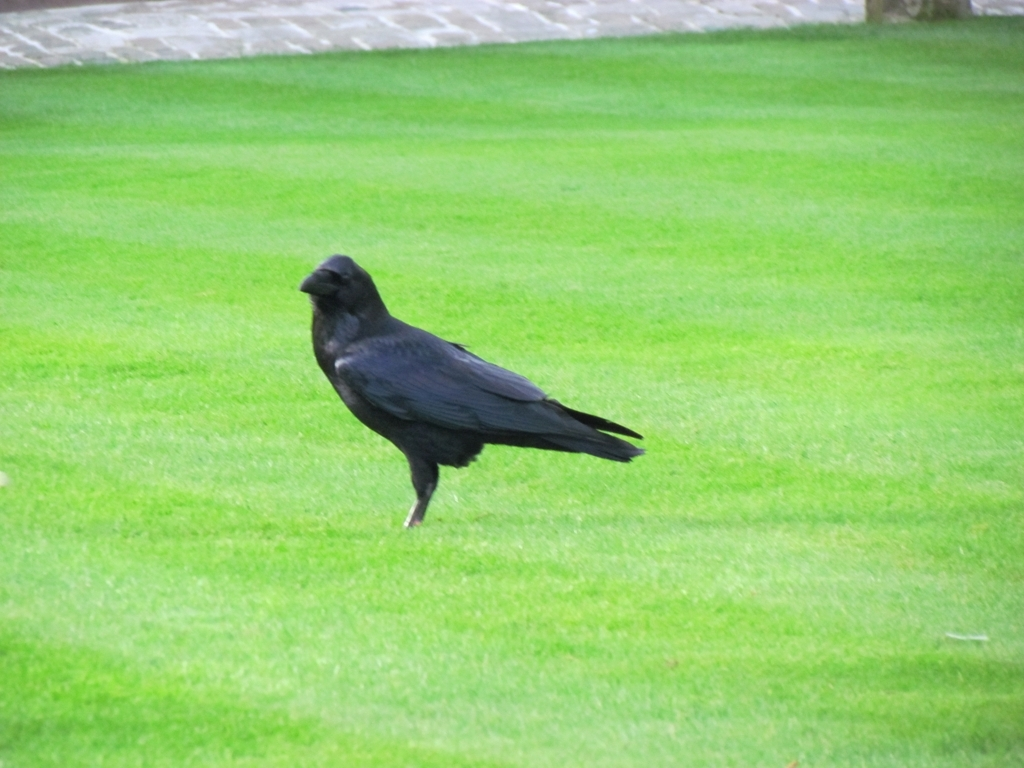What time of day does this photo appear to be taken? Given the soft lighting and the absence of harsh shadows, it looks like the photo was taken either early in the morning or late in the afternoon when the sunlight is more diffused. This gentle light offers a serene and calm feeling to the scene. Does the presence of the crow add anything to the photo? Absolutely, the crow adds a point of interest and a touch of life to the picture. Its dark silhouette provides a striking contrast against the green background, creating a focal point and adding to the overall aesthetic appeal. 